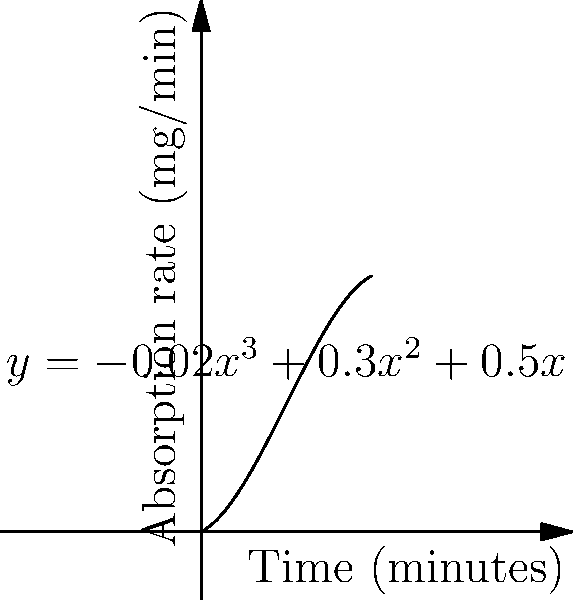The absorption rate of a specific nutrient in the small intestine can be modeled by the polynomial function $y = -0.02x^3 + 0.3x^2 + 0.5x$, where $y$ represents the absorption rate in mg/min and $x$ represents the time in minutes. At what time does the absorption rate reach its maximum value? To find the maximum absorption rate, we need to follow these steps:

1) The maximum point occurs where the derivative of the function equals zero. Let's find the derivative:

   $\frac{dy}{dx} = -0.06x^2 + 0.6x + 0.5$

2) Set the derivative equal to zero:

   $-0.06x^2 + 0.6x + 0.5 = 0$

3) This is a quadratic equation. We can solve it using the quadratic formula:
   $x = \frac{-b \pm \sqrt{b^2 - 4ac}}{2a}$

   Where $a = -0.06$, $b = 0.6$, and $c = 0.5$

4) Substituting these values:

   $x = \frac{-0.6 \pm \sqrt{0.6^2 - 4(-0.06)(0.5)}}{2(-0.06)}$

5) Simplifying:

   $x = \frac{-0.6 \pm \sqrt{0.36 + 0.12}}{-0.12} = \frac{-0.6 \pm \sqrt{0.48}}{-0.12} = \frac{-0.6 \pm 0.6928}{-0.12}$

6) This gives us two solutions:
   $x_1 = \frac{-0.6 + 0.6928}{-0.12} \approx 0.77$ minutes
   $x_2 = \frac{-0.6 - 0.6928}{-0.12} \approx 10.77$ minutes

7) By examining the graph or considering the context, we can see that the maximum occurs at the larger value, approximately 10.77 minutes.
Answer: 10.77 minutes 